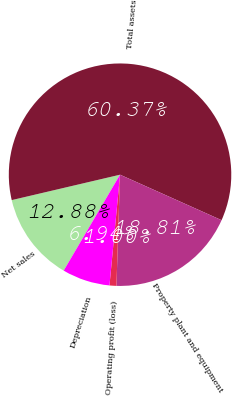Convert chart. <chart><loc_0><loc_0><loc_500><loc_500><pie_chart><fcel>Net sales<fcel>Total assets<fcel>Property plant and equipment<fcel>Operating profit (loss)<fcel>Depreciation<nl><fcel>12.88%<fcel>60.37%<fcel>18.81%<fcel>1.0%<fcel>6.94%<nl></chart> 